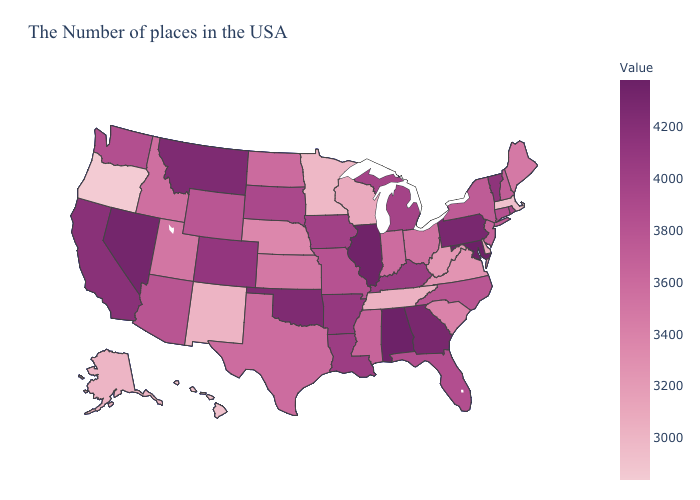Does West Virginia have the lowest value in the USA?
Be succinct. No. Does Maryland have the highest value in the USA?
Be succinct. Yes. Which states have the lowest value in the South?
Keep it brief. Tennessee. Does Maryland have the highest value in the South?
Write a very short answer. Yes. Which states have the lowest value in the USA?
Answer briefly. Oregon. Which states have the highest value in the USA?
Give a very brief answer. Maryland. 